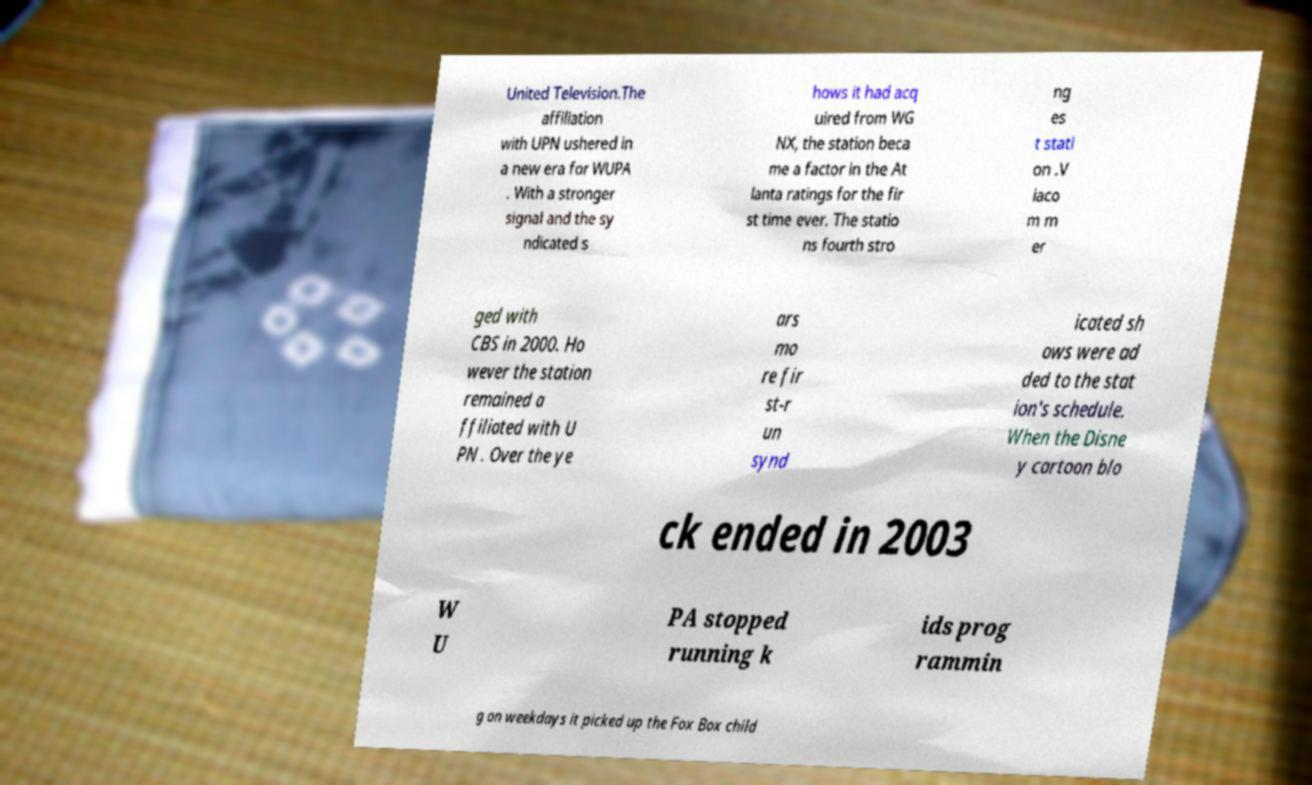Can you accurately transcribe the text from the provided image for me? United Television.The affiliation with UPN ushered in a new era for WUPA . With a stronger signal and the sy ndicated s hows it had acq uired from WG NX, the station beca me a factor in the At lanta ratings for the fir st time ever. The statio ns fourth stro ng es t stati on .V iaco m m er ged with CBS in 2000. Ho wever the station remained a ffiliated with U PN . Over the ye ars mo re fir st-r un synd icated sh ows were ad ded to the stat ion's schedule. When the Disne y cartoon blo ck ended in 2003 W U PA stopped running k ids prog rammin g on weekdays it picked up the Fox Box child 